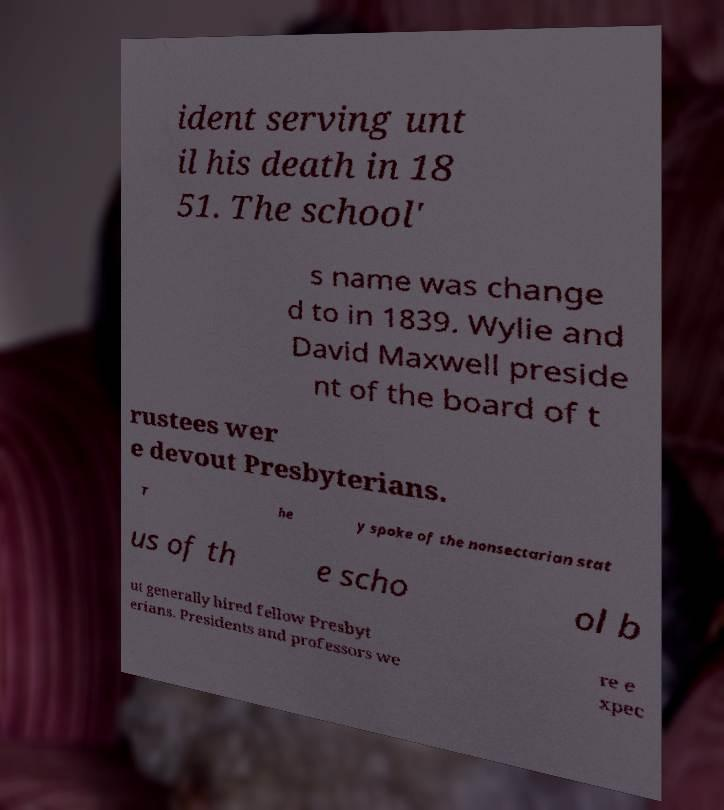Could you assist in decoding the text presented in this image and type it out clearly? ident serving unt il his death in 18 51. The school' s name was change d to in 1839. Wylie and David Maxwell preside nt of the board of t rustees wer e devout Presbyterians. T he y spoke of the nonsectarian stat us of th e scho ol b ut generally hired fellow Presbyt erians. Presidents and professors we re e xpec 